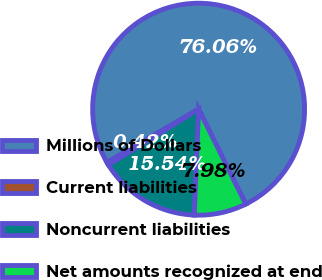Convert chart. <chart><loc_0><loc_0><loc_500><loc_500><pie_chart><fcel>Millions of Dollars<fcel>Current liabilities<fcel>Noncurrent liabilities<fcel>Net amounts recognized at end<nl><fcel>76.06%<fcel>0.42%<fcel>15.54%<fcel>7.98%<nl></chart> 